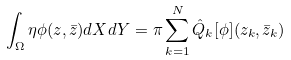<formula> <loc_0><loc_0><loc_500><loc_500>\int _ { \Omega } \eta \phi ( z , \bar { z } ) d X d Y = \pi \sum _ { k = 1 } ^ { N } \hat { Q } _ { k } [ \phi ] ( z _ { k } , \bar { z } _ { k } )</formula> 